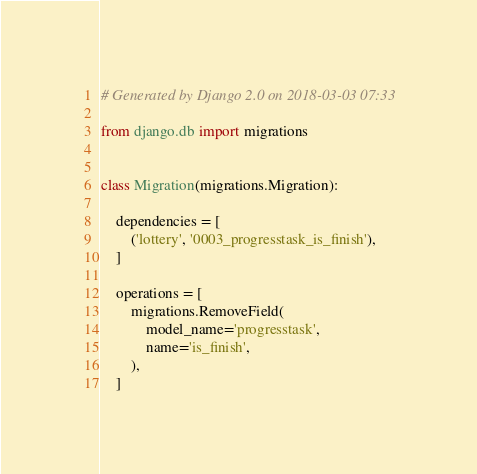Convert code to text. <code><loc_0><loc_0><loc_500><loc_500><_Python_># Generated by Django 2.0 on 2018-03-03 07:33

from django.db import migrations


class Migration(migrations.Migration):

    dependencies = [
        ('lottery', '0003_progresstask_is_finish'),
    ]

    operations = [
        migrations.RemoveField(
            model_name='progresstask',
            name='is_finish',
        ),
    ]
</code> 